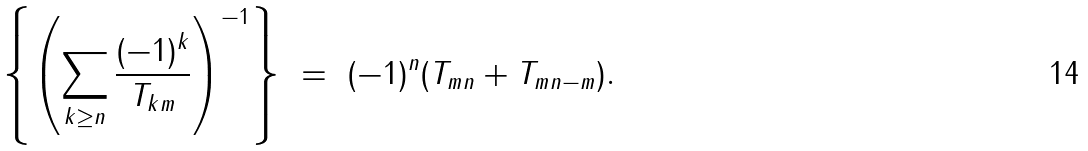Convert formula to latex. <formula><loc_0><loc_0><loc_500><loc_500>\left \{ \left ( \sum _ { k \geq n } \frac { ( - 1 ) ^ { k } } { T _ { k m } } \right ) ^ { - 1 } \right \} \ = \ ( - 1 ) ^ { n } ( T _ { m n } + T _ { m n - m } ) .</formula> 